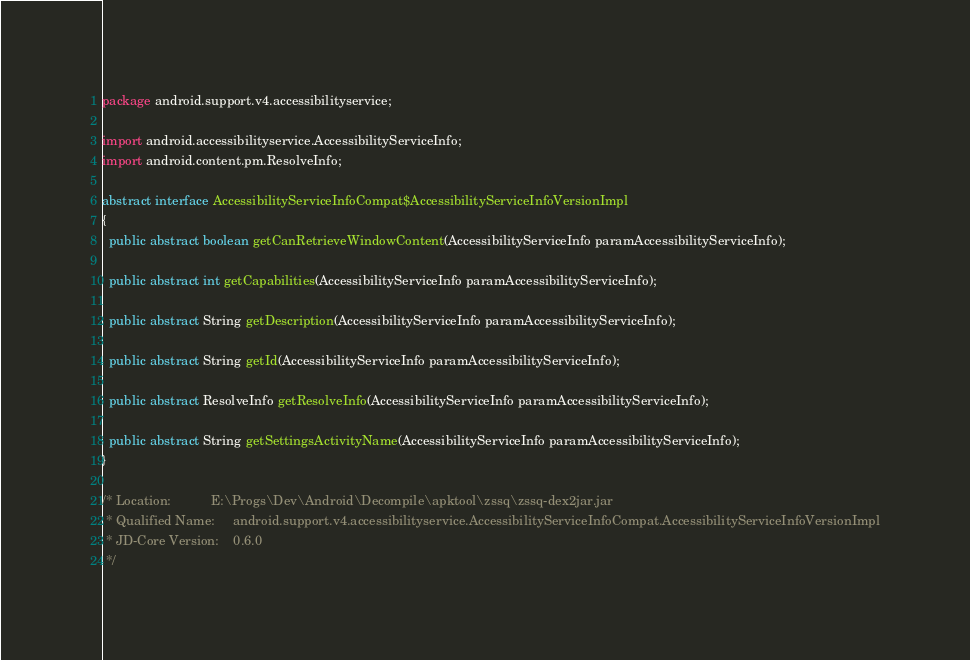Convert code to text. <code><loc_0><loc_0><loc_500><loc_500><_Java_>package android.support.v4.accessibilityservice;

import android.accessibilityservice.AccessibilityServiceInfo;
import android.content.pm.ResolveInfo;

abstract interface AccessibilityServiceInfoCompat$AccessibilityServiceInfoVersionImpl
{
  public abstract boolean getCanRetrieveWindowContent(AccessibilityServiceInfo paramAccessibilityServiceInfo);

  public abstract int getCapabilities(AccessibilityServiceInfo paramAccessibilityServiceInfo);

  public abstract String getDescription(AccessibilityServiceInfo paramAccessibilityServiceInfo);

  public abstract String getId(AccessibilityServiceInfo paramAccessibilityServiceInfo);

  public abstract ResolveInfo getResolveInfo(AccessibilityServiceInfo paramAccessibilityServiceInfo);

  public abstract String getSettingsActivityName(AccessibilityServiceInfo paramAccessibilityServiceInfo);
}

/* Location:           E:\Progs\Dev\Android\Decompile\apktool\zssq\zssq-dex2jar.jar
 * Qualified Name:     android.support.v4.accessibilityservice.AccessibilityServiceInfoCompat.AccessibilityServiceInfoVersionImpl
 * JD-Core Version:    0.6.0
 */</code> 